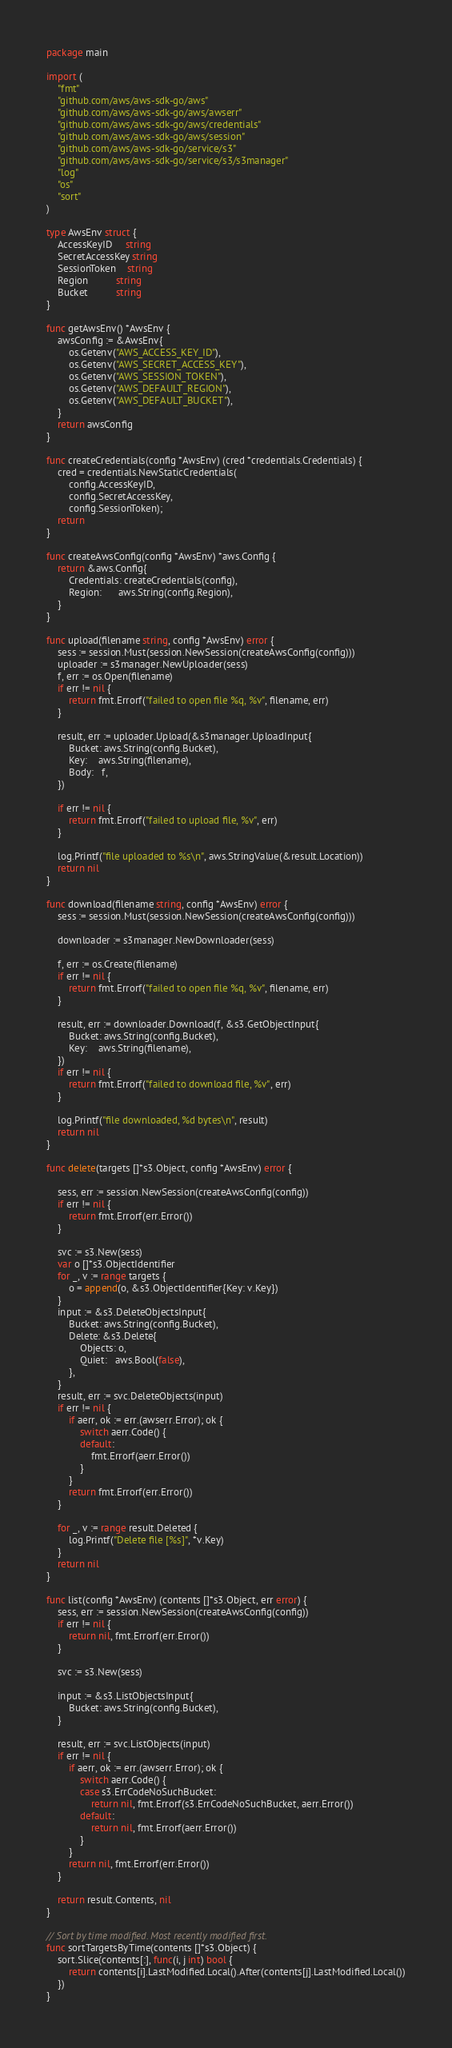<code> <loc_0><loc_0><loc_500><loc_500><_Go_>package main

import (
	"fmt"
	"github.com/aws/aws-sdk-go/aws"
	"github.com/aws/aws-sdk-go/aws/awserr"
	"github.com/aws/aws-sdk-go/aws/credentials"
	"github.com/aws/aws-sdk-go/aws/session"
	"github.com/aws/aws-sdk-go/service/s3"
	"github.com/aws/aws-sdk-go/service/s3/s3manager"
	"log"
	"os"
	"sort"
)

type AwsEnv struct {
	AccessKeyID     string
	SecretAccessKey string
	SessionToken    string
	Region          string
	Bucket          string
}

func getAwsEnv() *AwsEnv {
	awsConfig := &AwsEnv{
		os.Getenv("AWS_ACCESS_KEY_ID"),
		os.Getenv("AWS_SECRET_ACCESS_KEY"),
		os.Getenv("AWS_SESSION_TOKEN"),
		os.Getenv("AWS_DEFAULT_REGION"),
		os.Getenv("AWS_DEFAULT_BUCKET"),
	}
	return awsConfig
}

func createCredentials(config *AwsEnv) (cred *credentials.Credentials) {
	cred = credentials.NewStaticCredentials(
		config.AccessKeyID,
		config.SecretAccessKey,
		config.SessionToken);
	return
}

func createAwsConfig(config *AwsEnv) *aws.Config {
	return &aws.Config{
		Credentials: createCredentials(config),
		Region:      aws.String(config.Region),
	}
}

func upload(filename string, config *AwsEnv) error {
	sess := session.Must(session.NewSession(createAwsConfig(config)))
	uploader := s3manager.NewUploader(sess)
	f, err := os.Open(filename)
	if err != nil {
		return fmt.Errorf("failed to open file %q, %v", filename, err)
	}

	result, err := uploader.Upload(&s3manager.UploadInput{
		Bucket: aws.String(config.Bucket),
		Key:    aws.String(filename),
		Body:   f,
	})

	if err != nil {
		return fmt.Errorf("failed to upload file, %v", err)
	}

	log.Printf("file uploaded to %s\n", aws.StringValue(&result.Location))
	return nil
}

func download(filename string, config *AwsEnv) error {
	sess := session.Must(session.NewSession(createAwsConfig(config)))

	downloader := s3manager.NewDownloader(sess)

	f, err := os.Create(filename)
	if err != nil {
		return fmt.Errorf("failed to open file %q, %v", filename, err)
	}

	result, err := downloader.Download(f, &s3.GetObjectInput{
		Bucket: aws.String(config.Bucket),
		Key:    aws.String(filename),
	})
	if err != nil {
		return fmt.Errorf("failed to download file, %v", err)
	}

	log.Printf("file downloaded, %d bytes\n", result)
	return nil
}

func delete(targets []*s3.Object, config *AwsEnv) error {

	sess, err := session.NewSession(createAwsConfig(config))
	if err != nil {
		return fmt.Errorf(err.Error())
	}

	svc := s3.New(sess)
	var o []*s3.ObjectIdentifier
	for _, v := range targets {
		o = append(o, &s3.ObjectIdentifier{Key: v.Key})
	}
	input := &s3.DeleteObjectsInput{
		Bucket: aws.String(config.Bucket),
		Delete: &s3.Delete{
			Objects: o,
			Quiet:   aws.Bool(false),
		},
	}
	result, err := svc.DeleteObjects(input)
	if err != nil {
		if aerr, ok := err.(awserr.Error); ok {
			switch aerr.Code() {
			default:
				fmt.Errorf(aerr.Error())
			}
		}
		return fmt.Errorf(err.Error())
	}

	for _, v := range result.Deleted {
		log.Printf("Delete file [%s]", *v.Key)
	}
	return nil
}

func list(config *AwsEnv) (contents []*s3.Object, err error) {
	sess, err := session.NewSession(createAwsConfig(config))
	if err != nil {
		return nil, fmt.Errorf(err.Error())
	}

	svc := s3.New(sess)

	input := &s3.ListObjectsInput{
		Bucket: aws.String(config.Bucket),
	}

	result, err := svc.ListObjects(input)
	if err != nil {
		if aerr, ok := err.(awserr.Error); ok {
			switch aerr.Code() {
			case s3.ErrCodeNoSuchBucket:
				return nil, fmt.Errorf(s3.ErrCodeNoSuchBucket, aerr.Error())
			default:
				return nil, fmt.Errorf(aerr.Error())
			}
		}
		return nil, fmt.Errorf(err.Error())
	}

	return result.Contents, nil
}

// Sort by time modified. Most recently modified first.
func sortTargetsByTime(contents []*s3.Object) {
	sort.Slice(contents[:], func(i, j int) bool {
		return contents[i].LastModified.Local().After(contents[j].LastModified.Local())
	})
}
</code> 